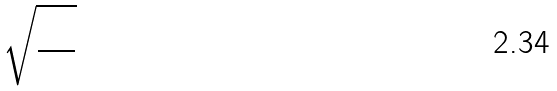<formula> <loc_0><loc_0><loc_500><loc_500>\sqrt { \frac { 1 0 } { 6 3 } }</formula> 